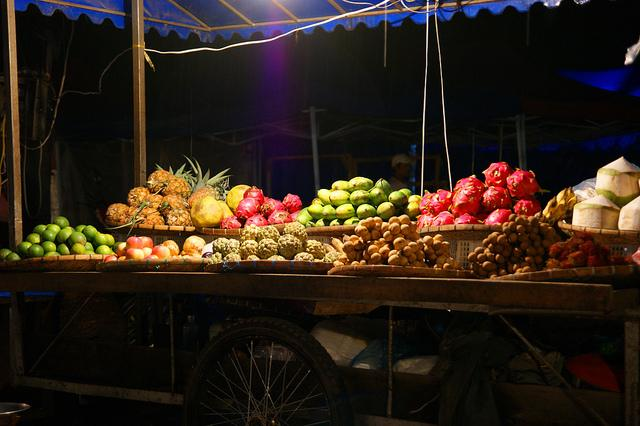What would you call this type of fruit seller? tropical 